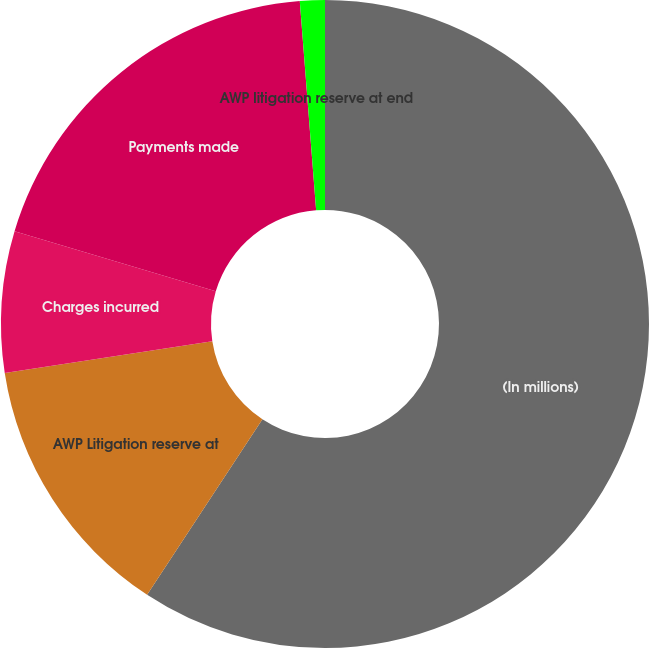<chart> <loc_0><loc_0><loc_500><loc_500><pie_chart><fcel>(In millions)<fcel>AWP Litigation reserve at<fcel>Charges incurred<fcel>Payments made<fcel>AWP litigation reserve at end<nl><fcel>59.25%<fcel>13.33%<fcel>7.04%<fcel>19.14%<fcel>1.24%<nl></chart> 